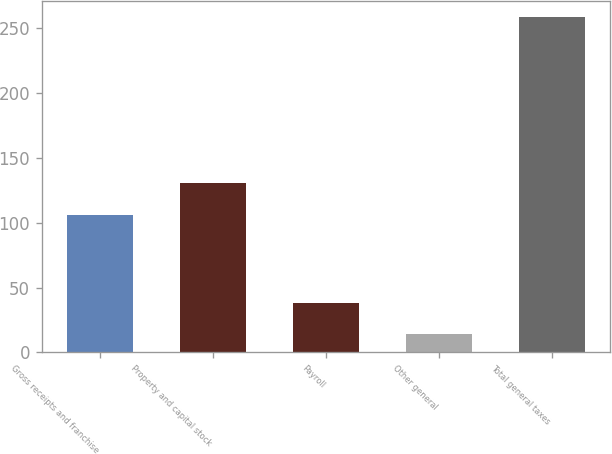<chart> <loc_0><loc_0><loc_500><loc_500><bar_chart><fcel>Gross receipts and franchise<fcel>Property and capital stock<fcel>Payroll<fcel>Other general<fcel>Total general taxes<nl><fcel>106<fcel>130.4<fcel>38.4<fcel>14<fcel>258<nl></chart> 